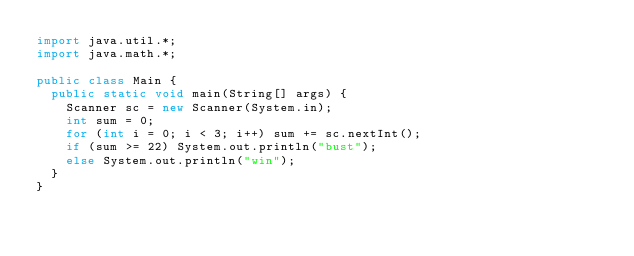Convert code to text. <code><loc_0><loc_0><loc_500><loc_500><_Java_>import java.util.*;
import java.math.*;

public class Main {
  public static void main(String[] args) {
    Scanner sc = new Scanner(System.in);
    int sum = 0;
    for (int i = 0; i < 3; i++) sum += sc.nextInt();
    if (sum >= 22) System.out.println("bust");
    else System.out.println("win");
  }
}
</code> 